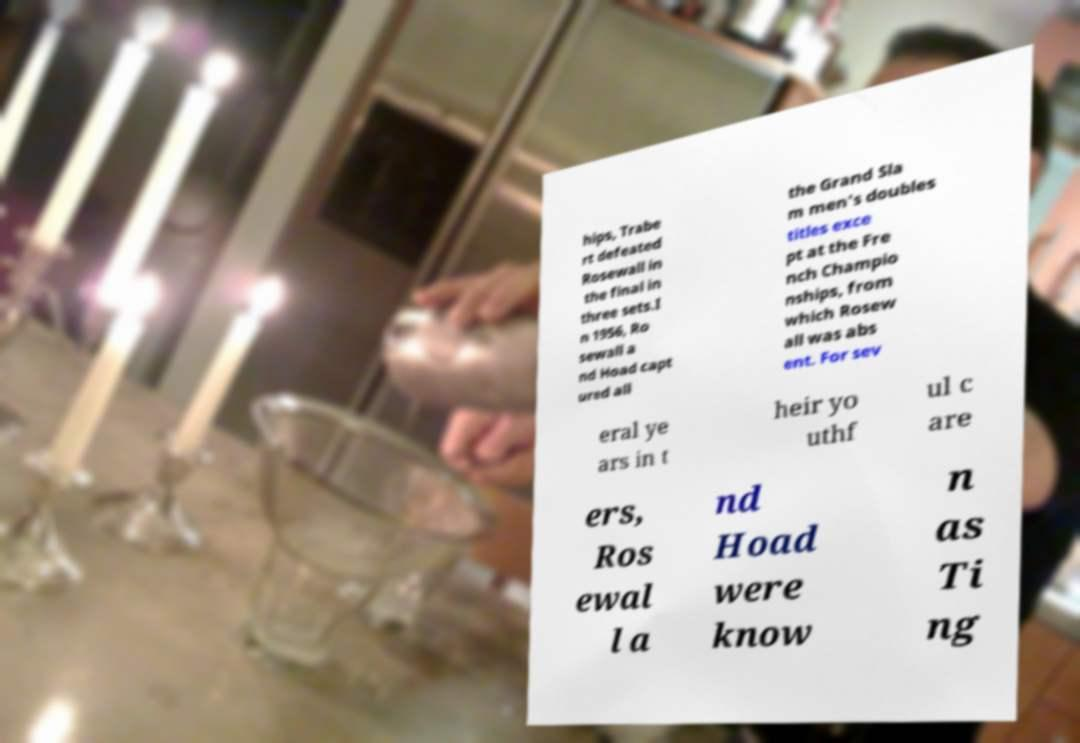What messages or text are displayed in this image? I need them in a readable, typed format. hips, Trabe rt defeated Rosewall in the final in three sets.I n 1956, Ro sewall a nd Hoad capt ured all the Grand Sla m men's doubles titles exce pt at the Fre nch Champio nships, from which Rosew all was abs ent. For sev eral ye ars in t heir yo uthf ul c are ers, Ros ewal l a nd Hoad were know n as Ti ng 